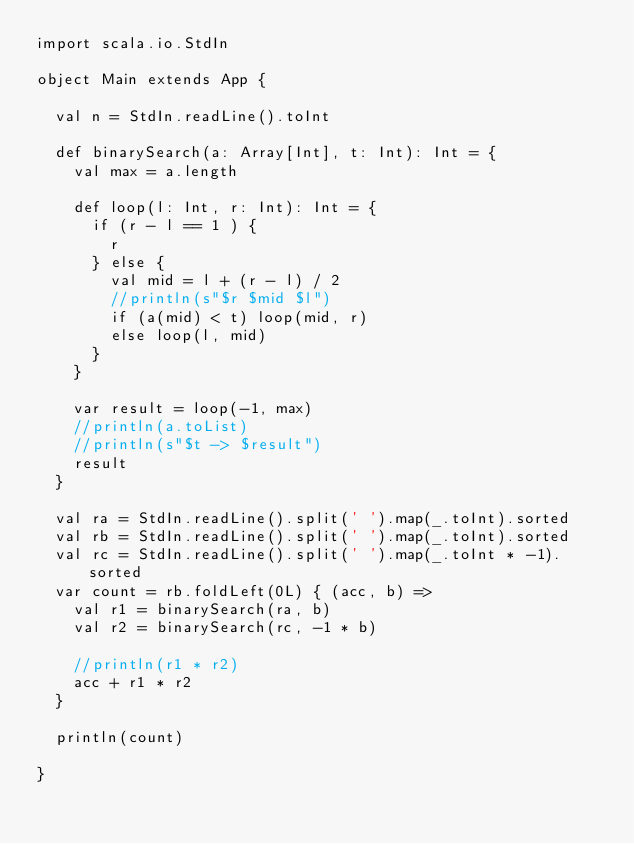Convert code to text. <code><loc_0><loc_0><loc_500><loc_500><_Scala_>import scala.io.StdIn

object Main extends App {

  val n = StdIn.readLine().toInt

  def binarySearch(a: Array[Int], t: Int): Int = {
    val max = a.length
    
    def loop(l: Int, r: Int): Int = {
      if (r - l == 1 ) {
        r
      } else {
        val mid = l + (r - l) / 2
        //println(s"$r $mid $l")
        if (a(mid) < t) loop(mid, r)
        else loop(l, mid)
      }
    }

    var result = loop(-1, max)
    //println(a.toList)
    //println(s"$t -> $result")
    result
  }

  val ra = StdIn.readLine().split(' ').map(_.toInt).sorted
  val rb = StdIn.readLine().split(' ').map(_.toInt).sorted
  val rc = StdIn.readLine().split(' ').map(_.toInt * -1).sorted
  var count = rb.foldLeft(0L) { (acc, b) =>
    val r1 = binarySearch(ra, b)
    val r2 = binarySearch(rc, -1 * b)

    //println(r1 * r2)
    acc + r1 * r2
  }

  println(count)

}</code> 